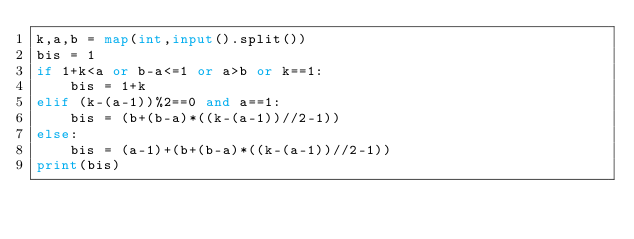Convert code to text. <code><loc_0><loc_0><loc_500><loc_500><_Python_>k,a,b = map(int,input().split())
bis = 1
if 1+k<a or b-a<=1 or a>b or k==1:
    bis = 1+k
elif (k-(a-1))%2==0 and a==1:
    bis = (b+(b-a)*((k-(a-1))//2-1))
else:
    bis = (a-1)+(b+(b-a)*((k-(a-1))//2-1))
print(bis)</code> 